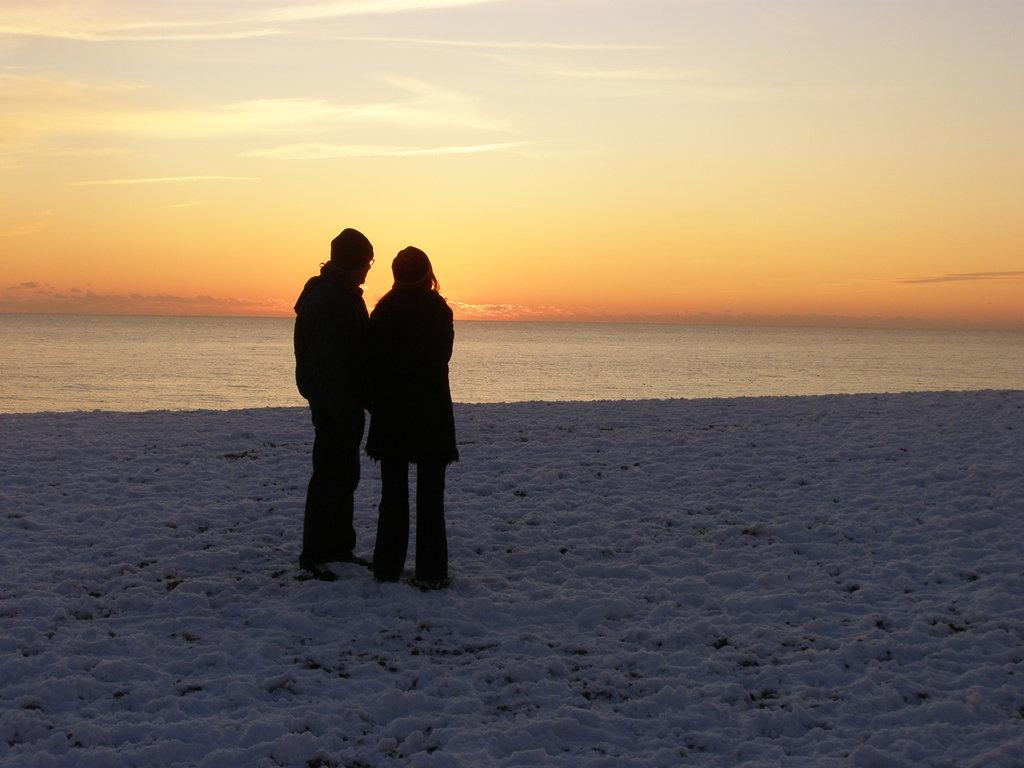Who or what can be seen in the image? There are people in the image. What is the weather like in the image? There is snow in the image, indicating a cold and likely wintery environment. What is the water visible in the image? The water could be a lake, river, or pond, but its exact nature is not specified. What else is present in the sky besides the snow? Clouds are present in the image. What books are the people reading in the image? There are no books visible in the image; the people are likely engaged in activities related to the snowy environment. Can you see a duck swimming in the water in the image? There is no duck present in the image; only people, snow, water, and clouds are visible. 